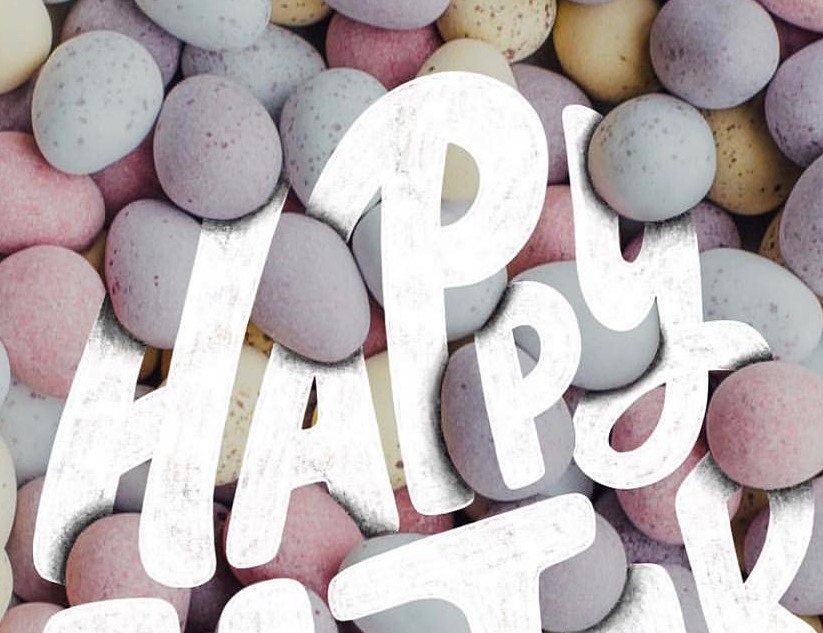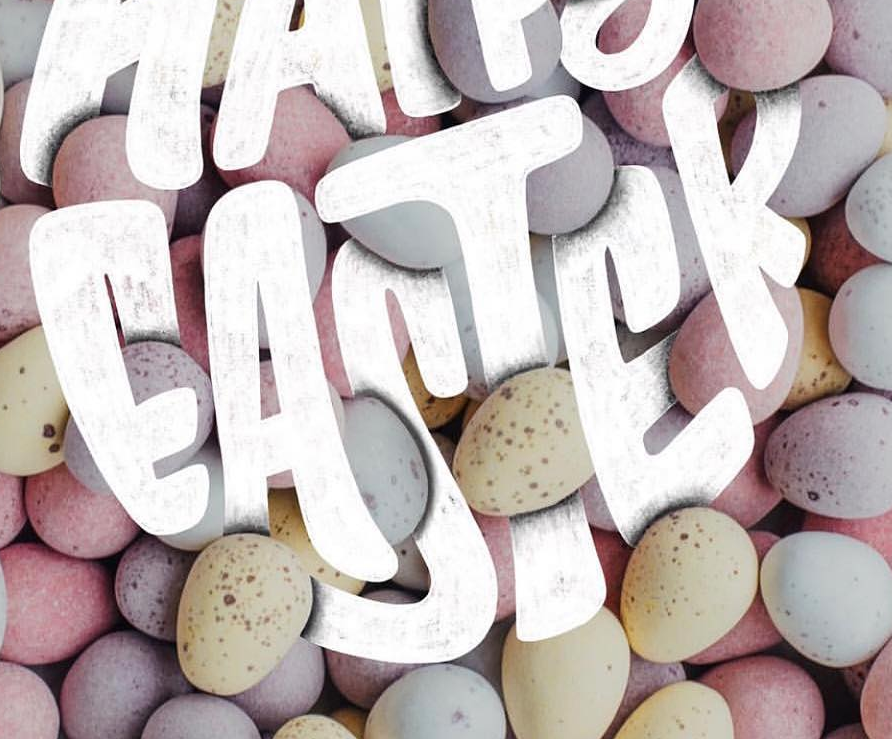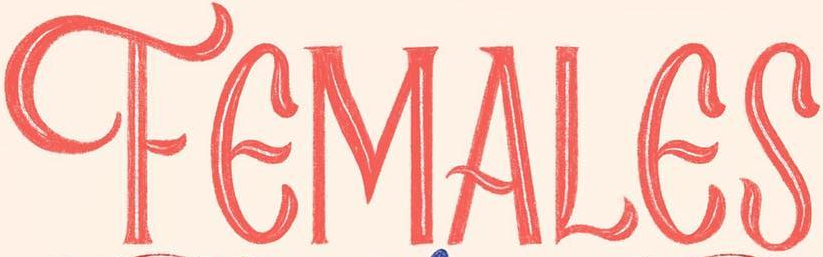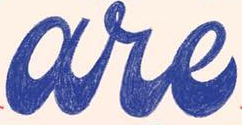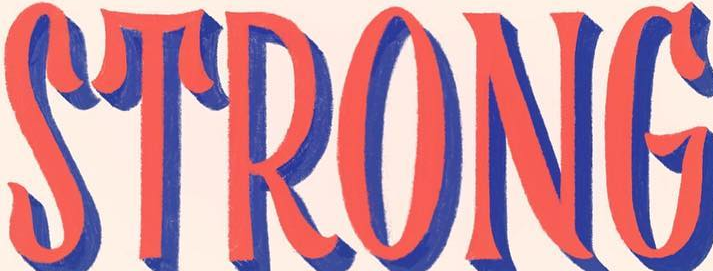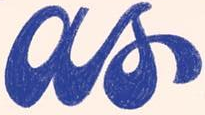What words are shown in these images in order, separated by a semicolon? HAPPY; EASTER; FEMALES; are; STRONG; as 